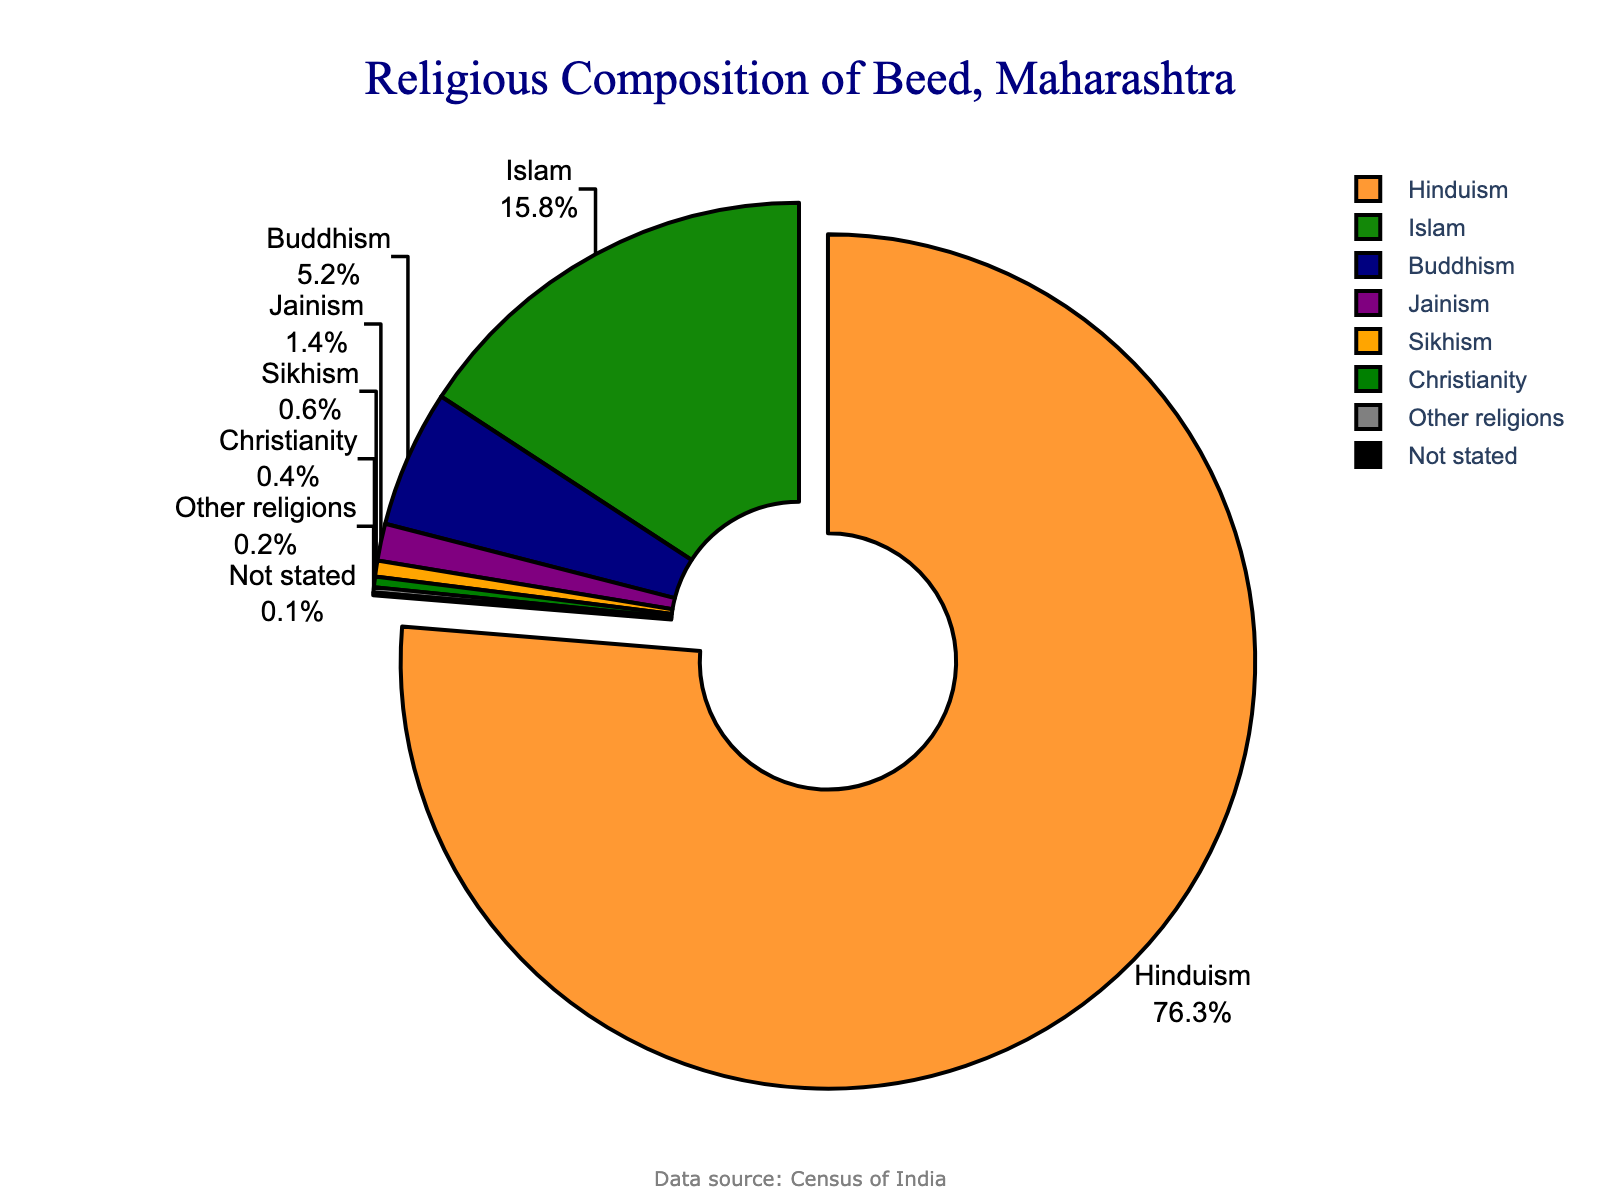Which religion has the highest percentage in Beed? By looking at the pie chart, the largest section of the chart is marked and labeled as Hinduism with the percentage of 76.3% highlighted.
Answer: Hinduism What is the combined percentage of Islam, Buddhism, and Jainism? From the chart, we can see the percentages for Islam (15.8%), Buddhism (5.2%), and Jainism (1.4%). Summing them up, 15.8 + 5.2 + 1.4 = 22.4%.
Answer: 22.4% Which religion has the smallest representation in Beed? The smallest slice of the chart is for the 'Not stated' category, with a percentage of 0.1%.
Answer: Not stated How much more is the percentage of Hindus compared to Muslims? The percentage of Hindus is 76.3%, and the percentage of Muslims is 15.8%. Subtracting these gives us 76.3 - 15.8 = 60.5%.
Answer: 60.5% Which religions have less than 1% representation in Beed? Observing the chart, we can see the categories with percentages less than 1% are Sikhism (0.6%), Christianity (0.4%), Other religions (0.2%), and Not stated (0.1%).
Answer: Sikhism, Christianity, Other religions, Not stated What is the combined percentage of all non-Hindu religions? From the chart, non-Hindu religions include Islam (15.8%), Buddhism (5.2%), Jainism (1.4%), Sikhism (0.6%), Christianity (0.4%), Other religions (0.2%), and Not stated (0.1%). Summing these percentages: 15.8 + 5.2 + 1.4 + 0.6 + 0.4 + 0.2 + 0.1 = 23.7%.
Answer: 23.7% Which section is pulled out from the pie chart and why? The pie chart pulls out the section with the highest percentage to highlight it, which is the Hinduism section with 76.3%.
Answer: Hinduism What is the difference between the percentages of the two largest religious groups? The two largest groups are Hinduism (76.3%) and Islam (15.8%). The difference is 76.3 - 15.8 = 60.5%.
Answer: 60.5% How does the representation of Buddhism compare to that of Jainism? The pie chart shows Buddhism at 5.2% and Jainism at 1.4%. Buddhism has a higher representation compared to Jainism.
Answer: Buddhism is higher Is there any religion with exactly 1% representation in Beed? Observing the pie chart, Jainism is shown to have 1.4%, which means no religion has exactly 1% representation.
Answer: No 